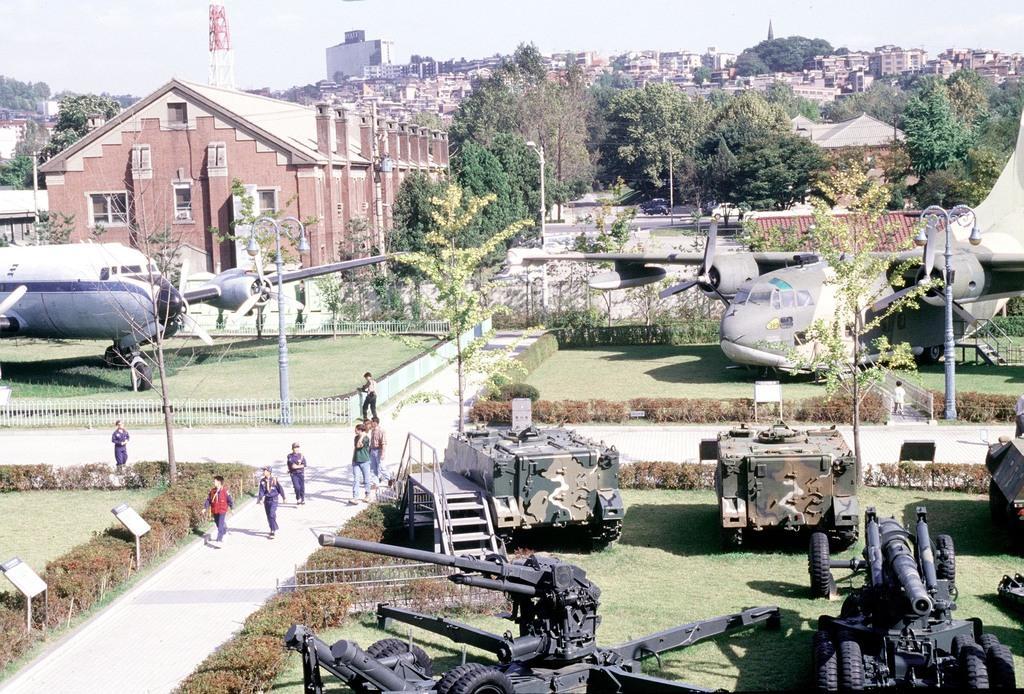Please provide a concise description of this image. In the background of the image there are buildings. There are trees. There aeroplanes. In the foreground of the image there are war tanks. There are people walking. There is grass. There is a tower. 